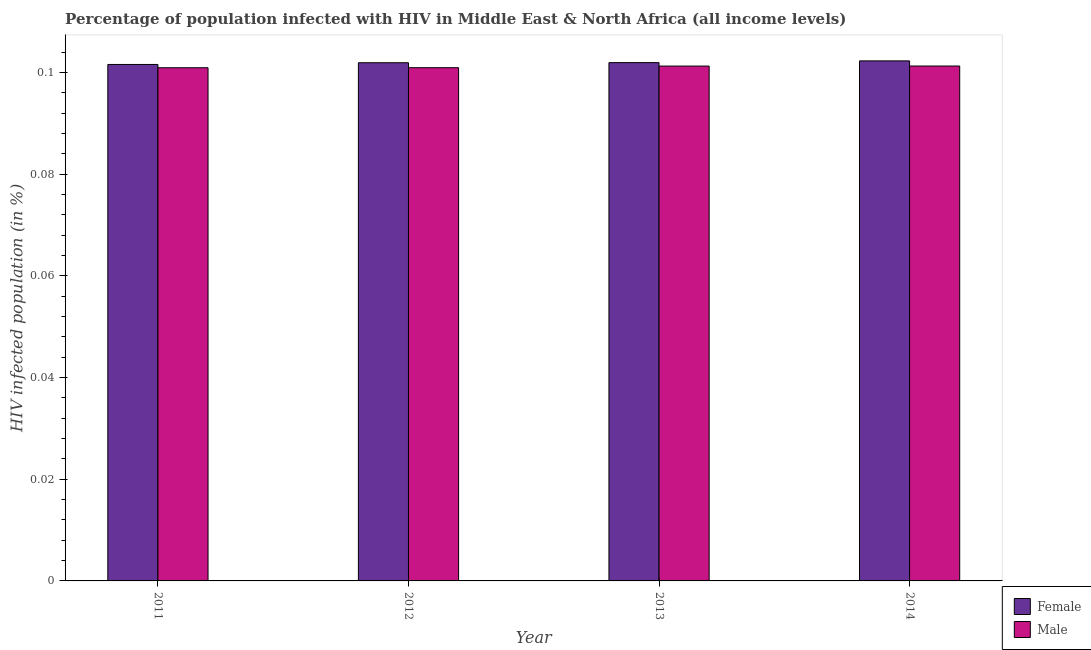How many bars are there on the 4th tick from the left?
Offer a terse response. 2. How many bars are there on the 1st tick from the right?
Offer a terse response. 2. What is the percentage of males who are infected with hiv in 2011?
Keep it short and to the point. 0.1. Across all years, what is the maximum percentage of females who are infected with hiv?
Ensure brevity in your answer.  0.1. Across all years, what is the minimum percentage of males who are infected with hiv?
Ensure brevity in your answer.  0.1. In which year was the percentage of males who are infected with hiv minimum?
Provide a succinct answer. 2011. What is the total percentage of females who are infected with hiv in the graph?
Your answer should be very brief. 0.41. What is the difference between the percentage of females who are infected with hiv in 2011 and that in 2014?
Your answer should be very brief. -0. What is the difference between the percentage of females who are infected with hiv in 2012 and the percentage of males who are infected with hiv in 2011?
Your response must be concise. 0. What is the average percentage of females who are infected with hiv per year?
Ensure brevity in your answer.  0.1. In how many years, is the percentage of males who are infected with hiv greater than 0.004 %?
Give a very brief answer. 4. What is the ratio of the percentage of males who are infected with hiv in 2011 to that in 2013?
Provide a succinct answer. 1. Is the percentage of males who are infected with hiv in 2011 less than that in 2013?
Offer a terse response. Yes. Is the difference between the percentage of females who are infected with hiv in 2011 and 2013 greater than the difference between the percentage of males who are infected with hiv in 2011 and 2013?
Your answer should be compact. No. What is the difference between the highest and the second highest percentage of males who are infected with hiv?
Your response must be concise. 7.26557411100115e-6. What is the difference between the highest and the lowest percentage of males who are infected with hiv?
Keep it short and to the point. 0. What does the 2nd bar from the left in 2011 represents?
Offer a terse response. Male. Are all the bars in the graph horizontal?
Keep it short and to the point. No. Does the graph contain grids?
Provide a succinct answer. No. Where does the legend appear in the graph?
Make the answer very short. Bottom right. How are the legend labels stacked?
Give a very brief answer. Vertical. What is the title of the graph?
Ensure brevity in your answer.  Percentage of population infected with HIV in Middle East & North Africa (all income levels). What is the label or title of the Y-axis?
Your response must be concise. HIV infected population (in %). What is the HIV infected population (in %) of Female in 2011?
Give a very brief answer. 0.1. What is the HIV infected population (in %) of Male in 2011?
Your response must be concise. 0.1. What is the HIV infected population (in %) in Female in 2012?
Provide a succinct answer. 0.1. What is the HIV infected population (in %) in Male in 2012?
Your response must be concise. 0.1. What is the HIV infected population (in %) of Female in 2013?
Your response must be concise. 0.1. What is the HIV infected population (in %) of Male in 2013?
Make the answer very short. 0.1. What is the HIV infected population (in %) of Female in 2014?
Offer a very short reply. 0.1. What is the HIV infected population (in %) of Male in 2014?
Give a very brief answer. 0.1. Across all years, what is the maximum HIV infected population (in %) of Female?
Keep it short and to the point. 0.1. Across all years, what is the maximum HIV infected population (in %) of Male?
Offer a very short reply. 0.1. Across all years, what is the minimum HIV infected population (in %) of Female?
Make the answer very short. 0.1. Across all years, what is the minimum HIV infected population (in %) of Male?
Your answer should be compact. 0.1. What is the total HIV infected population (in %) in Female in the graph?
Give a very brief answer. 0.41. What is the total HIV infected population (in %) in Male in the graph?
Ensure brevity in your answer.  0.4. What is the difference between the HIV infected population (in %) of Female in 2011 and that in 2012?
Keep it short and to the point. -0. What is the difference between the HIV infected population (in %) of Female in 2011 and that in 2013?
Your answer should be compact. -0. What is the difference between the HIV infected population (in %) in Male in 2011 and that in 2013?
Ensure brevity in your answer.  -0. What is the difference between the HIV infected population (in %) in Female in 2011 and that in 2014?
Provide a short and direct response. -0. What is the difference between the HIV infected population (in %) of Male in 2011 and that in 2014?
Provide a short and direct response. -0. What is the difference between the HIV infected population (in %) in Male in 2012 and that in 2013?
Keep it short and to the point. -0. What is the difference between the HIV infected population (in %) in Female in 2012 and that in 2014?
Provide a short and direct response. -0. What is the difference between the HIV infected population (in %) in Male in 2012 and that in 2014?
Provide a short and direct response. -0. What is the difference between the HIV infected population (in %) of Female in 2013 and that in 2014?
Ensure brevity in your answer.  -0. What is the difference between the HIV infected population (in %) in Female in 2011 and the HIV infected population (in %) in Male in 2012?
Keep it short and to the point. 0. What is the difference between the HIV infected population (in %) of Female in 2012 and the HIV infected population (in %) of Male in 2013?
Your answer should be very brief. 0. What is the difference between the HIV infected population (in %) of Female in 2012 and the HIV infected population (in %) of Male in 2014?
Your response must be concise. 0. What is the difference between the HIV infected population (in %) of Female in 2013 and the HIV infected population (in %) of Male in 2014?
Make the answer very short. 0. What is the average HIV infected population (in %) of Female per year?
Your answer should be very brief. 0.1. What is the average HIV infected population (in %) in Male per year?
Offer a very short reply. 0.1. In the year 2011, what is the difference between the HIV infected population (in %) of Female and HIV infected population (in %) of Male?
Keep it short and to the point. 0. In the year 2013, what is the difference between the HIV infected population (in %) in Female and HIV infected population (in %) in Male?
Offer a very short reply. 0. In the year 2014, what is the difference between the HIV infected population (in %) of Female and HIV infected population (in %) of Male?
Provide a short and direct response. 0. What is the ratio of the HIV infected population (in %) in Male in 2011 to that in 2012?
Ensure brevity in your answer.  1. What is the ratio of the HIV infected population (in %) in Female in 2011 to that in 2013?
Make the answer very short. 1. What is the ratio of the HIV infected population (in %) of Male in 2011 to that in 2014?
Your answer should be compact. 1. What is the ratio of the HIV infected population (in %) in Female in 2012 to that in 2013?
Keep it short and to the point. 1. What is the ratio of the HIV infected population (in %) in Female in 2012 to that in 2014?
Give a very brief answer. 1. What is the ratio of the HIV infected population (in %) in Male in 2012 to that in 2014?
Your response must be concise. 1. What is the ratio of the HIV infected population (in %) in Female in 2013 to that in 2014?
Offer a very short reply. 1. What is the ratio of the HIV infected population (in %) in Male in 2013 to that in 2014?
Give a very brief answer. 1. What is the difference between the highest and the second highest HIV infected population (in %) of Male?
Make the answer very short. 0. What is the difference between the highest and the lowest HIV infected population (in %) in Female?
Keep it short and to the point. 0. 